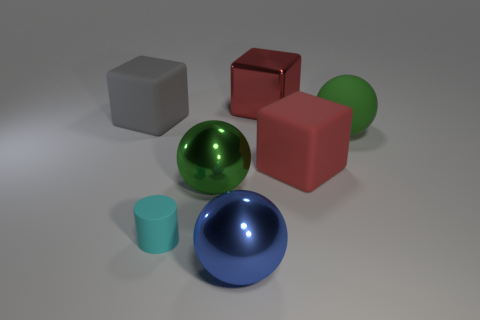Subtract all metallic spheres. How many spheres are left? 1 Subtract all cyan balls. How many red blocks are left? 2 Add 3 tiny gray objects. How many objects exist? 10 Subtract all blocks. How many objects are left? 4 Subtract all blue metallic balls. Subtract all large brown rubber cubes. How many objects are left? 6 Add 1 large metallic blocks. How many large metallic blocks are left? 2 Add 6 small yellow metallic cylinders. How many small yellow metallic cylinders exist? 6 Subtract 1 blue balls. How many objects are left? 6 